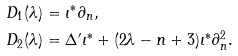Convert formula to latex. <formula><loc_0><loc_0><loc_500><loc_500>D _ { 1 } ( \lambda ) & = \iota ^ { * } \partial _ { n } , \\ D _ { 2 } ( \lambda ) & = \Delta ^ { \prime } \iota ^ { * } + ( 2 \lambda - n + 3 ) \iota ^ { * } \partial _ { n } ^ { 2 } .</formula> 